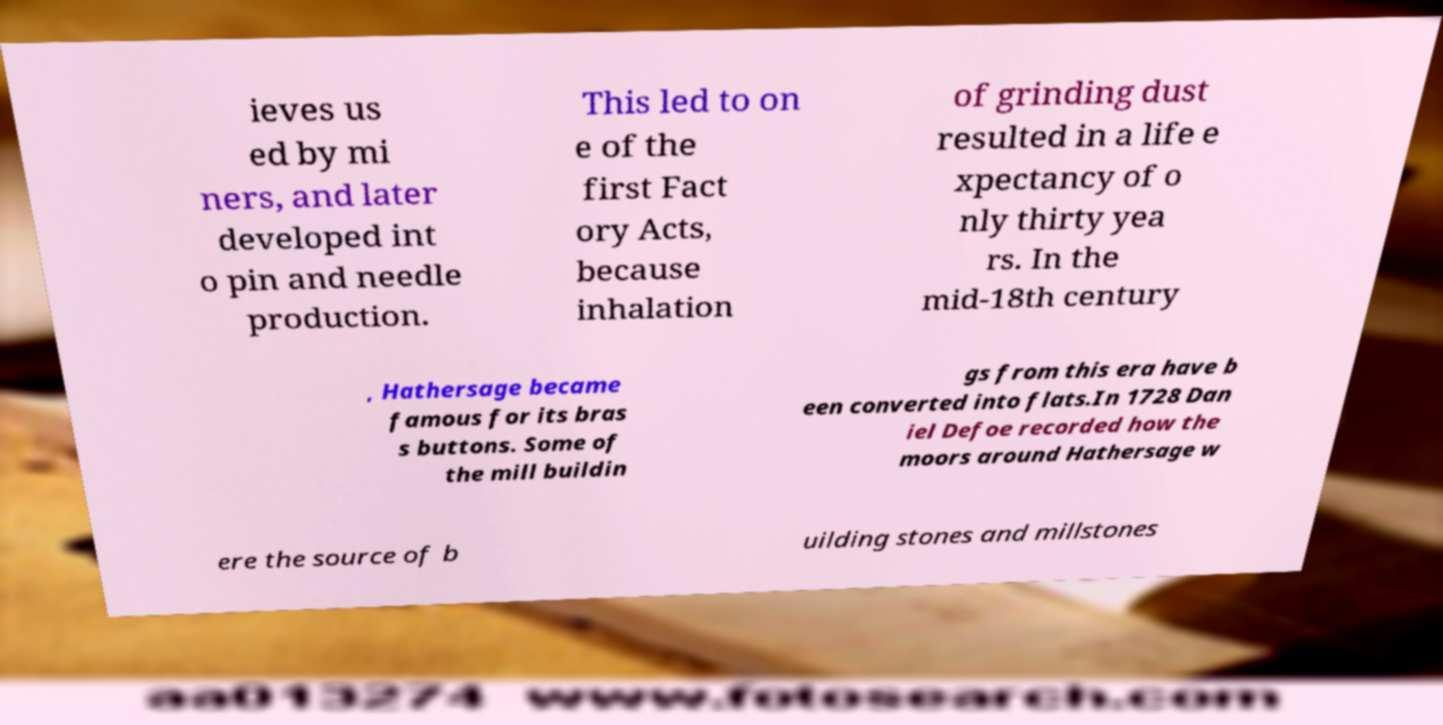I need the written content from this picture converted into text. Can you do that? ieves us ed by mi ners, and later developed int o pin and needle production. This led to on e of the first Fact ory Acts, because inhalation of grinding dust resulted in a life e xpectancy of o nly thirty yea rs. In the mid-18th century , Hathersage became famous for its bras s buttons. Some of the mill buildin gs from this era have b een converted into flats.In 1728 Dan iel Defoe recorded how the moors around Hathersage w ere the source of b uilding stones and millstones 